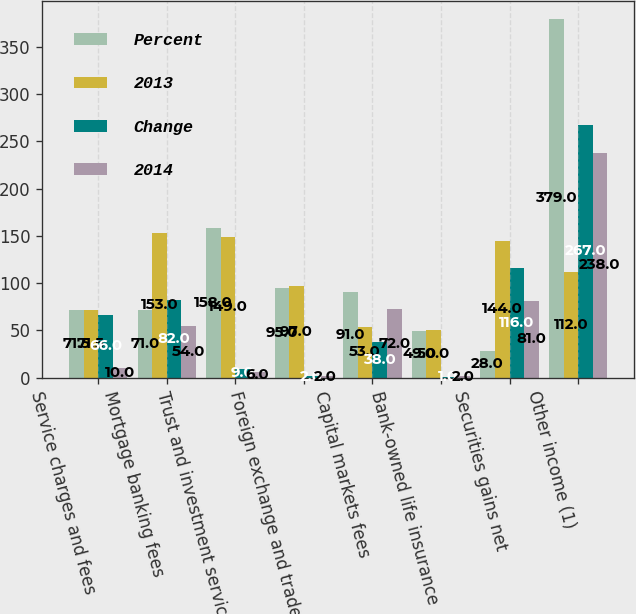Convert chart. <chart><loc_0><loc_0><loc_500><loc_500><stacked_bar_chart><ecel><fcel>Service charges and fees<fcel>Mortgage banking fees<fcel>Trust and investment services<fcel>Foreign exchange and trade<fcel>Capital markets fees<fcel>Bank-owned life insurance<fcel>Securities gains net<fcel>Other income (1)<nl><fcel>Percent<fcel>71.5<fcel>71<fcel>158<fcel>95<fcel>91<fcel>49<fcel>28<fcel>379<nl><fcel>2013<fcel>71.5<fcel>153<fcel>149<fcel>97<fcel>53<fcel>50<fcel>144<fcel>112<nl><fcel>Change<fcel>66<fcel>82<fcel>9<fcel>2<fcel>38<fcel>1<fcel>116<fcel>267<nl><fcel>2014<fcel>10<fcel>54<fcel>6<fcel>2<fcel>72<fcel>2<fcel>81<fcel>238<nl></chart> 